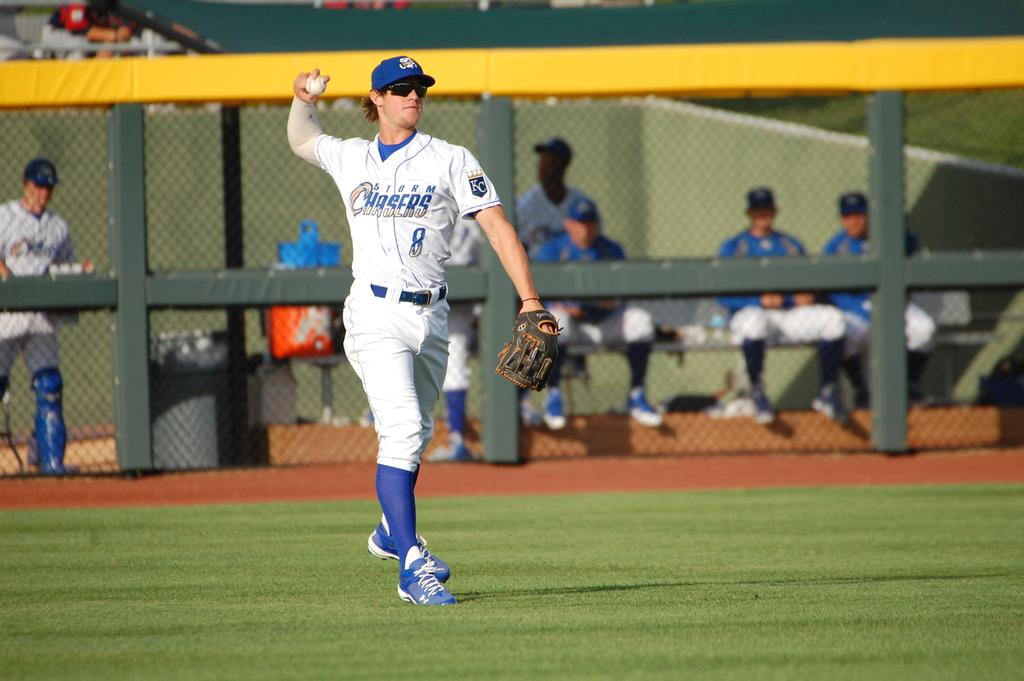What team does the player play on?
Provide a short and direct response. Storm chasers. Which number is on the shirt?
Give a very brief answer. 8. 